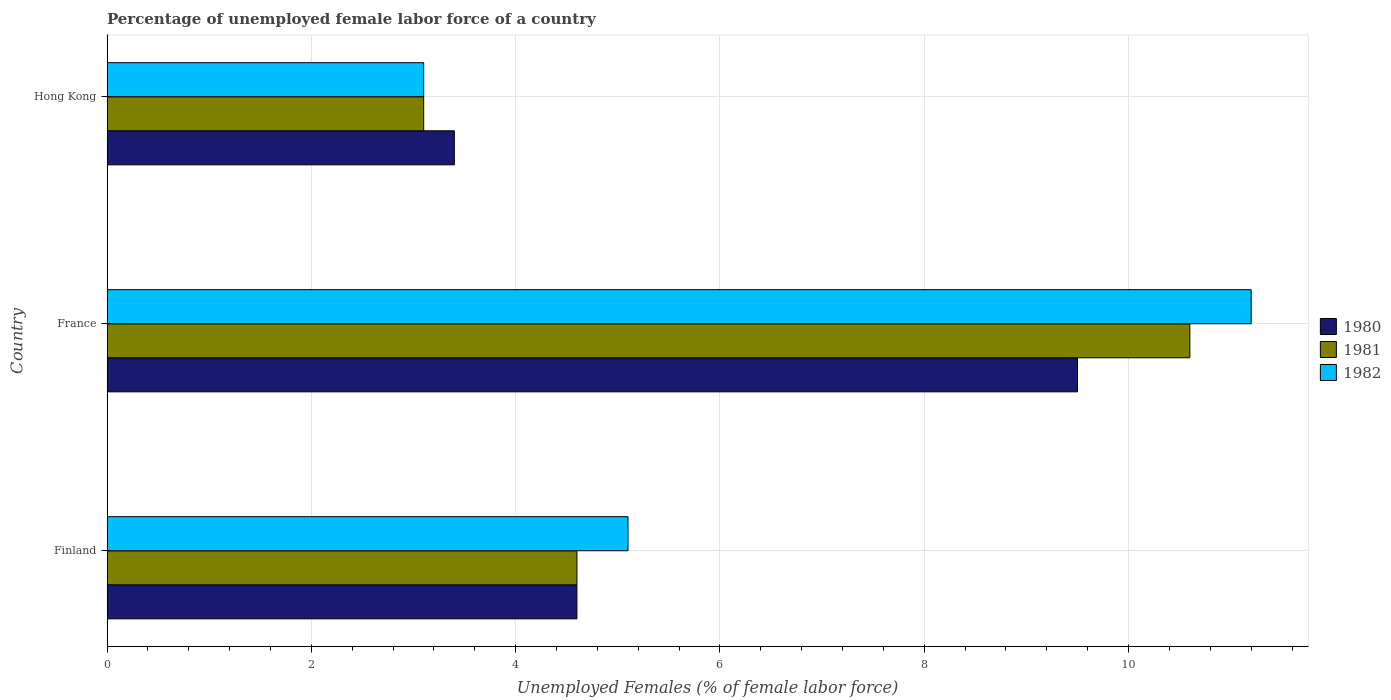What is the label of the 2nd group of bars from the top?
Make the answer very short. France. In how many cases, is the number of bars for a given country not equal to the number of legend labels?
Offer a terse response. 0. What is the percentage of unemployed female labor force in 1980 in Hong Kong?
Keep it short and to the point. 3.4. Across all countries, what is the maximum percentage of unemployed female labor force in 1981?
Your response must be concise. 10.6. Across all countries, what is the minimum percentage of unemployed female labor force in 1980?
Ensure brevity in your answer.  3.4. In which country was the percentage of unemployed female labor force in 1981 maximum?
Your answer should be very brief. France. In which country was the percentage of unemployed female labor force in 1982 minimum?
Make the answer very short. Hong Kong. What is the difference between the percentage of unemployed female labor force in 1982 in France and that in Hong Kong?
Provide a short and direct response. 8.1. What is the difference between the percentage of unemployed female labor force in 1981 in Hong Kong and the percentage of unemployed female labor force in 1980 in Finland?
Your answer should be very brief. -1.5. What is the average percentage of unemployed female labor force in 1981 per country?
Give a very brief answer. 6.1. What is the ratio of the percentage of unemployed female labor force in 1981 in France to that in Hong Kong?
Provide a succinct answer. 3.42. Is the difference between the percentage of unemployed female labor force in 1982 in France and Hong Kong greater than the difference between the percentage of unemployed female labor force in 1981 in France and Hong Kong?
Give a very brief answer. Yes. What is the difference between the highest and the second highest percentage of unemployed female labor force in 1980?
Offer a very short reply. 4.9. What is the difference between the highest and the lowest percentage of unemployed female labor force in 1982?
Provide a succinct answer. 8.1. What does the 1st bar from the bottom in Finland represents?
Your answer should be very brief. 1980. How many bars are there?
Offer a very short reply. 9. How many countries are there in the graph?
Offer a terse response. 3. Does the graph contain grids?
Provide a short and direct response. Yes. Where does the legend appear in the graph?
Ensure brevity in your answer.  Center right. How many legend labels are there?
Keep it short and to the point. 3. What is the title of the graph?
Offer a very short reply. Percentage of unemployed female labor force of a country. Does "2005" appear as one of the legend labels in the graph?
Offer a terse response. No. What is the label or title of the X-axis?
Give a very brief answer. Unemployed Females (% of female labor force). What is the Unemployed Females (% of female labor force) of 1980 in Finland?
Offer a very short reply. 4.6. What is the Unemployed Females (% of female labor force) in 1981 in Finland?
Offer a very short reply. 4.6. What is the Unemployed Females (% of female labor force) of 1982 in Finland?
Offer a very short reply. 5.1. What is the Unemployed Females (% of female labor force) in 1981 in France?
Offer a terse response. 10.6. What is the Unemployed Females (% of female labor force) in 1982 in France?
Provide a succinct answer. 11.2. What is the Unemployed Females (% of female labor force) in 1980 in Hong Kong?
Your answer should be very brief. 3.4. What is the Unemployed Females (% of female labor force) in 1981 in Hong Kong?
Offer a terse response. 3.1. What is the Unemployed Females (% of female labor force) in 1982 in Hong Kong?
Offer a very short reply. 3.1. Across all countries, what is the maximum Unemployed Females (% of female labor force) in 1980?
Offer a terse response. 9.5. Across all countries, what is the maximum Unemployed Females (% of female labor force) of 1981?
Make the answer very short. 10.6. Across all countries, what is the maximum Unemployed Females (% of female labor force) of 1982?
Your response must be concise. 11.2. Across all countries, what is the minimum Unemployed Females (% of female labor force) of 1980?
Offer a very short reply. 3.4. Across all countries, what is the minimum Unemployed Females (% of female labor force) of 1981?
Make the answer very short. 3.1. Across all countries, what is the minimum Unemployed Females (% of female labor force) in 1982?
Offer a terse response. 3.1. What is the total Unemployed Females (% of female labor force) in 1981 in the graph?
Your answer should be compact. 18.3. What is the difference between the Unemployed Females (% of female labor force) of 1982 in Finland and that in France?
Provide a short and direct response. -6.1. What is the difference between the Unemployed Females (% of female labor force) in 1981 in Finland and that in Hong Kong?
Your response must be concise. 1.5. What is the difference between the Unemployed Females (% of female labor force) of 1982 in Finland and that in Hong Kong?
Your answer should be very brief. 2. What is the difference between the Unemployed Females (% of female labor force) in 1982 in France and that in Hong Kong?
Give a very brief answer. 8.1. What is the difference between the Unemployed Females (% of female labor force) in 1980 in Finland and the Unemployed Females (% of female labor force) in 1981 in France?
Your response must be concise. -6. What is the difference between the Unemployed Females (% of female labor force) in 1980 in Finland and the Unemployed Females (% of female labor force) in 1982 in France?
Give a very brief answer. -6.6. What is the difference between the Unemployed Females (% of female labor force) in 1981 in Finland and the Unemployed Females (% of female labor force) in 1982 in France?
Your response must be concise. -6.6. What is the difference between the Unemployed Females (% of female labor force) in 1980 in Finland and the Unemployed Females (% of female labor force) in 1981 in Hong Kong?
Your answer should be compact. 1.5. What is the difference between the Unemployed Females (% of female labor force) in 1980 in Finland and the Unemployed Females (% of female labor force) in 1982 in Hong Kong?
Provide a succinct answer. 1.5. What is the difference between the Unemployed Females (% of female labor force) in 1981 in France and the Unemployed Females (% of female labor force) in 1982 in Hong Kong?
Your answer should be very brief. 7.5. What is the average Unemployed Females (% of female labor force) in 1980 per country?
Offer a very short reply. 5.83. What is the average Unemployed Females (% of female labor force) in 1982 per country?
Your answer should be compact. 6.47. What is the difference between the Unemployed Females (% of female labor force) in 1980 and Unemployed Females (% of female labor force) in 1981 in Finland?
Provide a short and direct response. 0. What is the difference between the Unemployed Females (% of female labor force) of 1981 and Unemployed Females (% of female labor force) of 1982 in Finland?
Ensure brevity in your answer.  -0.5. What is the difference between the Unemployed Females (% of female labor force) in 1980 and Unemployed Females (% of female labor force) in 1981 in France?
Make the answer very short. -1.1. What is the difference between the Unemployed Females (% of female labor force) in 1980 and Unemployed Females (% of female labor force) in 1981 in Hong Kong?
Make the answer very short. 0.3. What is the difference between the Unemployed Females (% of female labor force) in 1981 and Unemployed Females (% of female labor force) in 1982 in Hong Kong?
Offer a terse response. 0. What is the ratio of the Unemployed Females (% of female labor force) of 1980 in Finland to that in France?
Keep it short and to the point. 0.48. What is the ratio of the Unemployed Females (% of female labor force) in 1981 in Finland to that in France?
Offer a very short reply. 0.43. What is the ratio of the Unemployed Females (% of female labor force) in 1982 in Finland to that in France?
Your answer should be very brief. 0.46. What is the ratio of the Unemployed Females (% of female labor force) of 1980 in Finland to that in Hong Kong?
Offer a very short reply. 1.35. What is the ratio of the Unemployed Females (% of female labor force) of 1981 in Finland to that in Hong Kong?
Make the answer very short. 1.48. What is the ratio of the Unemployed Females (% of female labor force) in 1982 in Finland to that in Hong Kong?
Make the answer very short. 1.65. What is the ratio of the Unemployed Females (% of female labor force) in 1980 in France to that in Hong Kong?
Make the answer very short. 2.79. What is the ratio of the Unemployed Females (% of female labor force) in 1981 in France to that in Hong Kong?
Offer a very short reply. 3.42. What is the ratio of the Unemployed Females (% of female labor force) of 1982 in France to that in Hong Kong?
Offer a terse response. 3.61. What is the difference between the highest and the second highest Unemployed Females (% of female labor force) of 1982?
Keep it short and to the point. 6.1. What is the difference between the highest and the lowest Unemployed Females (% of female labor force) of 1982?
Provide a succinct answer. 8.1. 